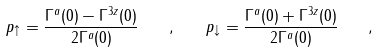Convert formula to latex. <formula><loc_0><loc_0><loc_500><loc_500>p _ { \uparrow } = \frac { \Gamma ^ { a } ( 0 ) - \Gamma ^ { 3 z } ( 0 ) } { 2 \Gamma ^ { a } ( 0 ) } \quad , \quad p _ { \downarrow } = \frac { \Gamma ^ { a } ( 0 ) + \Gamma ^ { 3 z } ( 0 ) } { 2 \Gamma ^ { a } ( 0 ) } \quad ,</formula> 